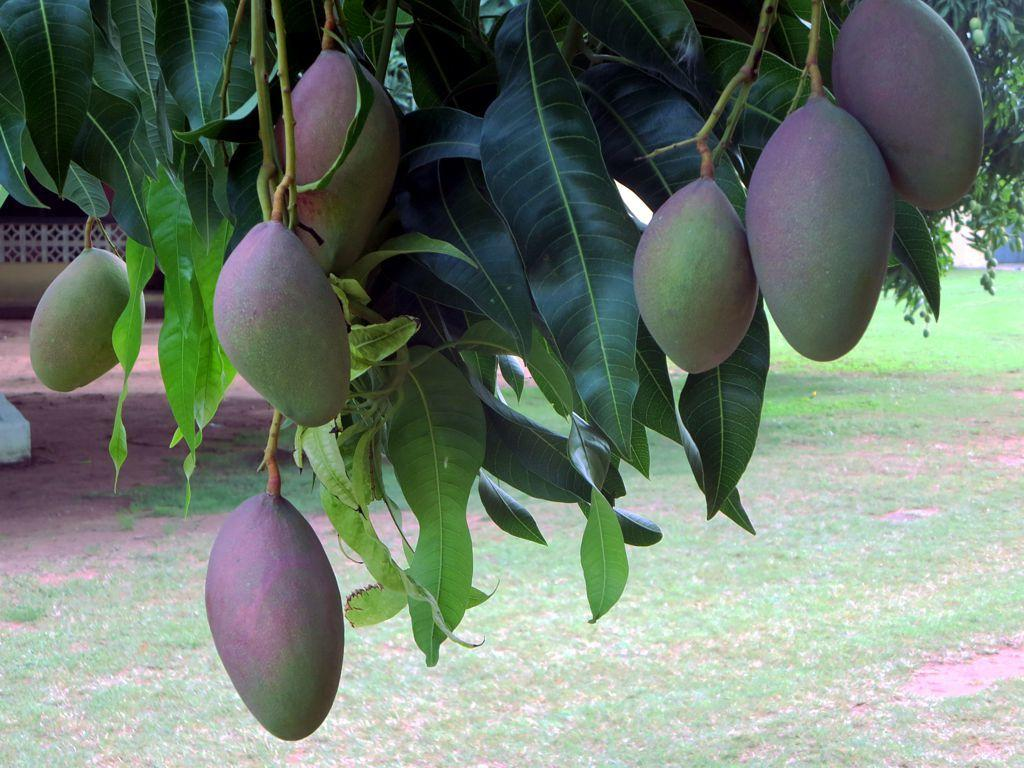What type of fruit can be seen on the tree in the foreground of the image? There are mangoes on a tree in the foreground of the image. What type of vegetation is visible in the background of the image? There is grass land visible in the background of the image. What can be seen on the left side of the image? There appears to be a wall on the left side of the image. Can you see a mitten hanging on the wall in the image? There is no mitten present in the image; only mangoes, grass land, and a wall are visible. 